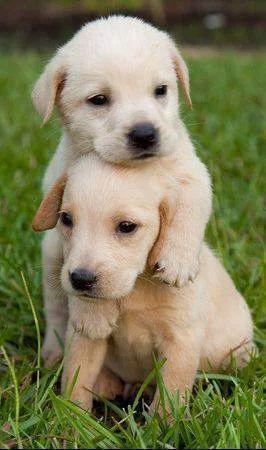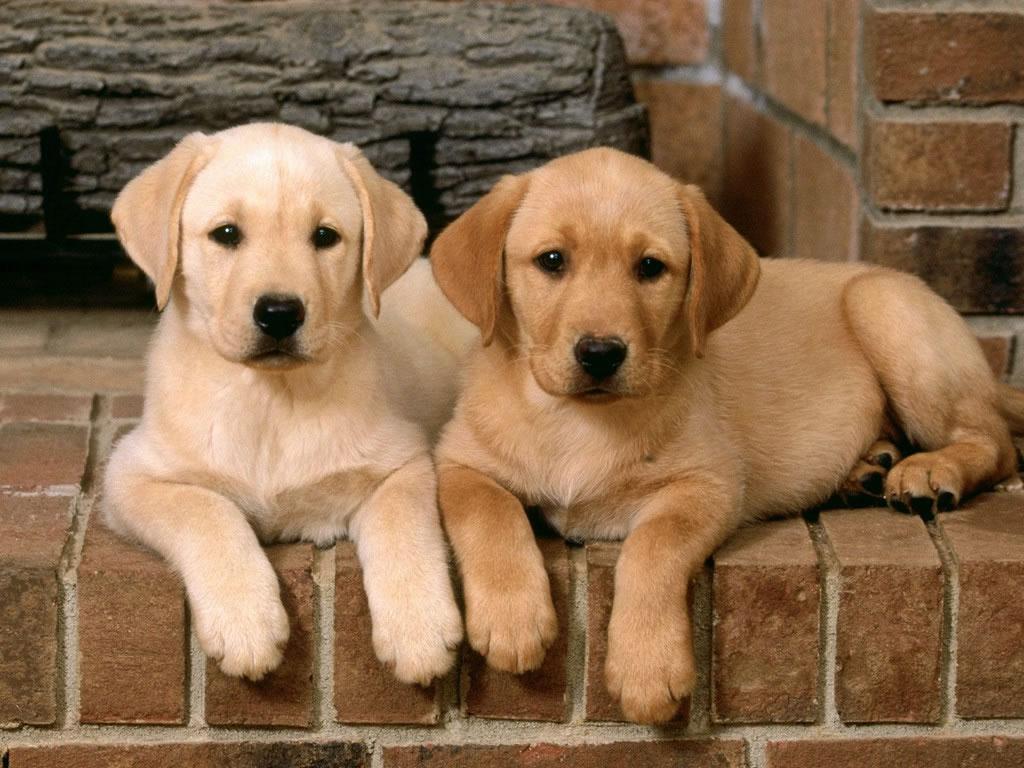The first image is the image on the left, the second image is the image on the right. Assess this claim about the two images: "There is one black dog". Correct or not? Answer yes or no. No. The first image is the image on the left, the second image is the image on the right. Analyze the images presented: Is the assertion "There are exactly five dogs in the image on the left." valid? Answer yes or no. No. 